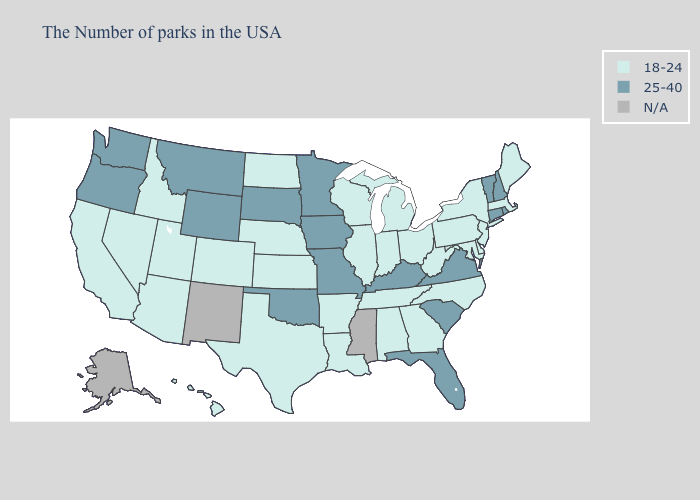Which states have the lowest value in the USA?
Answer briefly. Maine, Massachusetts, New York, New Jersey, Delaware, Maryland, Pennsylvania, North Carolina, West Virginia, Ohio, Georgia, Michigan, Indiana, Alabama, Tennessee, Wisconsin, Illinois, Louisiana, Arkansas, Kansas, Nebraska, Texas, North Dakota, Colorado, Utah, Arizona, Idaho, Nevada, California, Hawaii. Does Virginia have the lowest value in the South?
Write a very short answer. No. Name the states that have a value in the range 25-40?
Write a very short answer. Rhode Island, New Hampshire, Vermont, Connecticut, Virginia, South Carolina, Florida, Kentucky, Missouri, Minnesota, Iowa, Oklahoma, South Dakota, Wyoming, Montana, Washington, Oregon. What is the value of Oklahoma?
Be succinct. 25-40. What is the value of Nevada?
Keep it brief. 18-24. Does Indiana have the highest value in the USA?
Be succinct. No. What is the value of Kentucky?
Be succinct. 25-40. Name the states that have a value in the range 25-40?
Keep it brief. Rhode Island, New Hampshire, Vermont, Connecticut, Virginia, South Carolina, Florida, Kentucky, Missouri, Minnesota, Iowa, Oklahoma, South Dakota, Wyoming, Montana, Washington, Oregon. Among the states that border Massachusetts , does Vermont have the lowest value?
Keep it brief. No. Name the states that have a value in the range N/A?
Short answer required. Mississippi, New Mexico, Alaska. What is the value of Wisconsin?
Concise answer only. 18-24. Does North Carolina have the lowest value in the South?
Quick response, please. Yes. How many symbols are there in the legend?
Give a very brief answer. 3. 